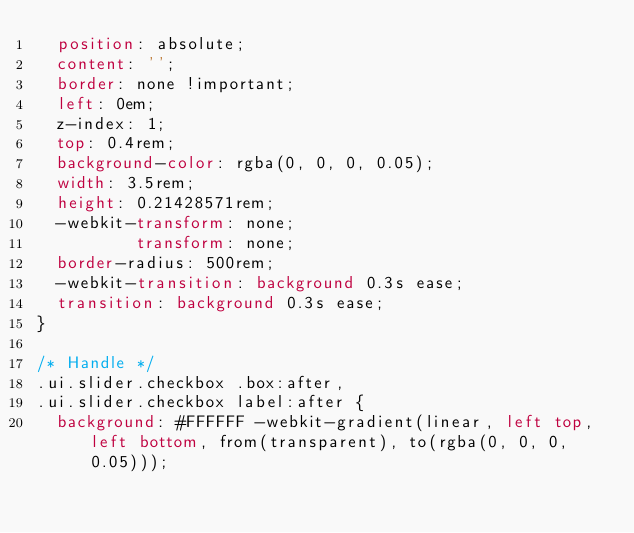Convert code to text. <code><loc_0><loc_0><loc_500><loc_500><_CSS_>  position: absolute;
  content: '';
  border: none !important;
  left: 0em;
  z-index: 1;
  top: 0.4rem;
  background-color: rgba(0, 0, 0, 0.05);
  width: 3.5rem;
  height: 0.21428571rem;
  -webkit-transform: none;
          transform: none;
  border-radius: 500rem;
  -webkit-transition: background 0.3s ease;
  transition: background 0.3s ease;
}

/* Handle */
.ui.slider.checkbox .box:after,
.ui.slider.checkbox label:after {
  background: #FFFFFF -webkit-gradient(linear, left top, left bottom, from(transparent), to(rgba(0, 0, 0, 0.05)));</code> 